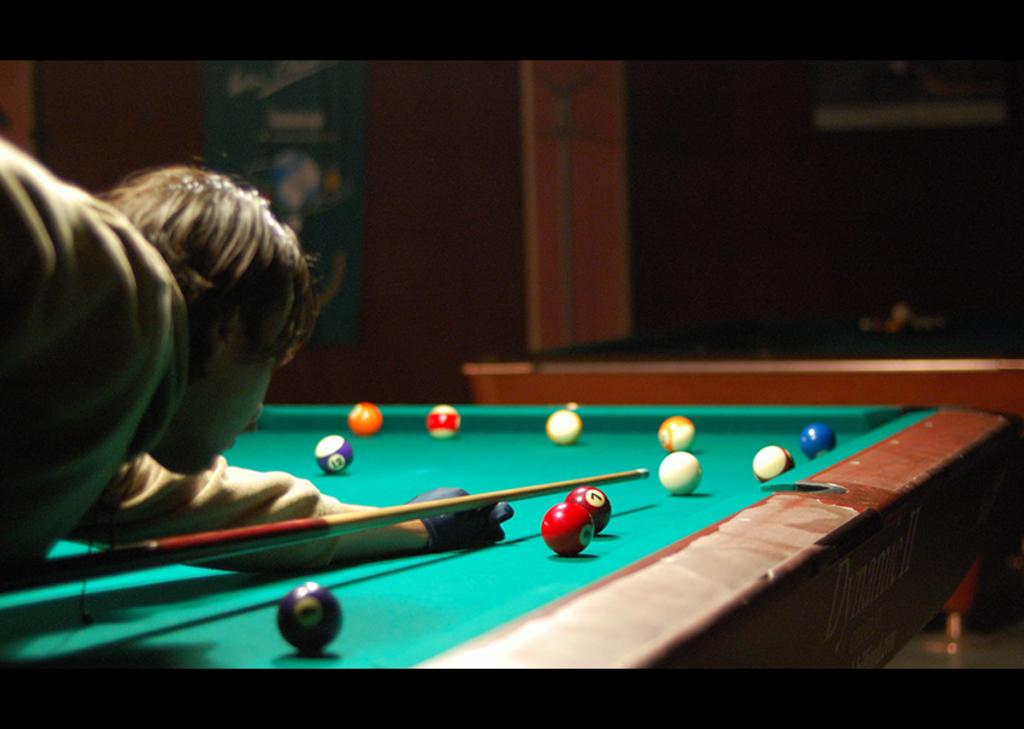Who is the main subject in the image? There is a man in the image. What is the man doing in the image? The man is playing a snooker game. What type of weather can be seen in the image? The image does not depict any weather conditions, as it is focused on the man playing snooker. Where is the faucet located in the image? There is no faucet present in the image. 